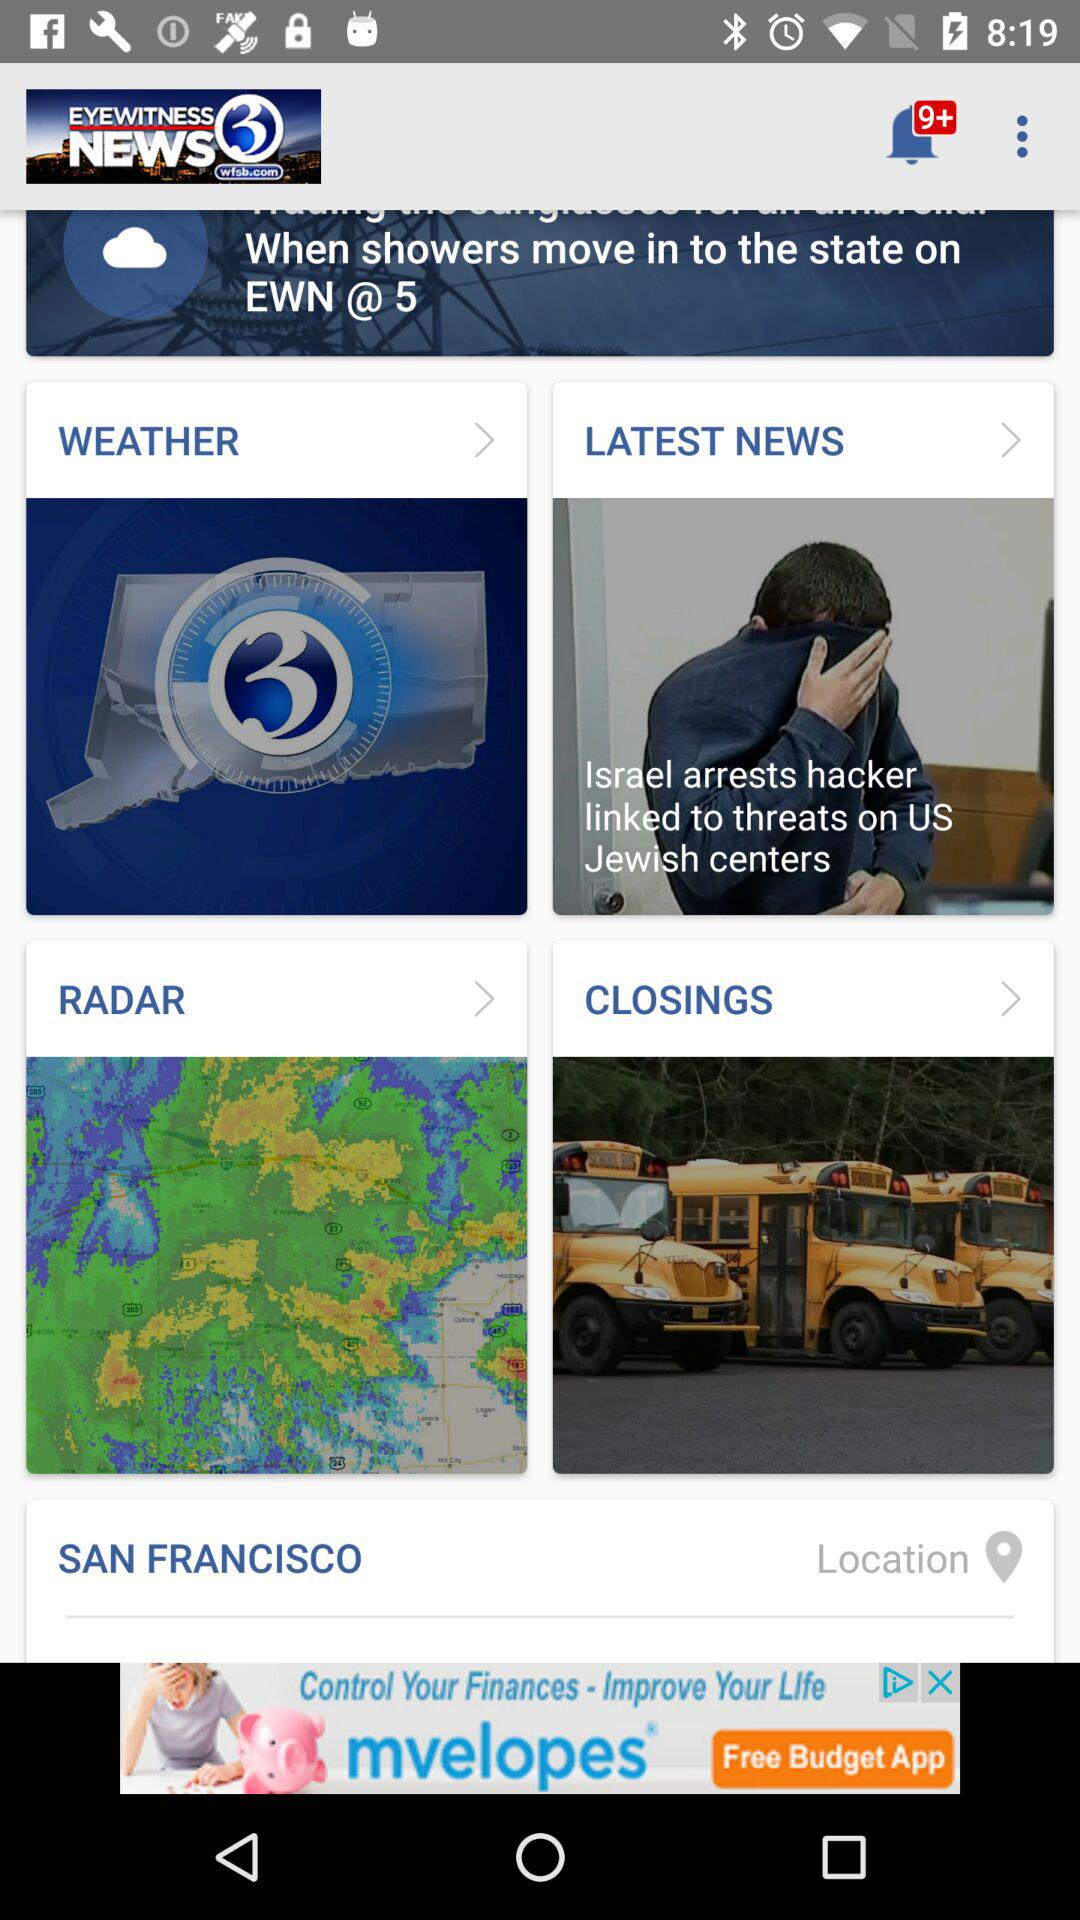How many unread notifications are there pending? There are 9+ unread notifications. 